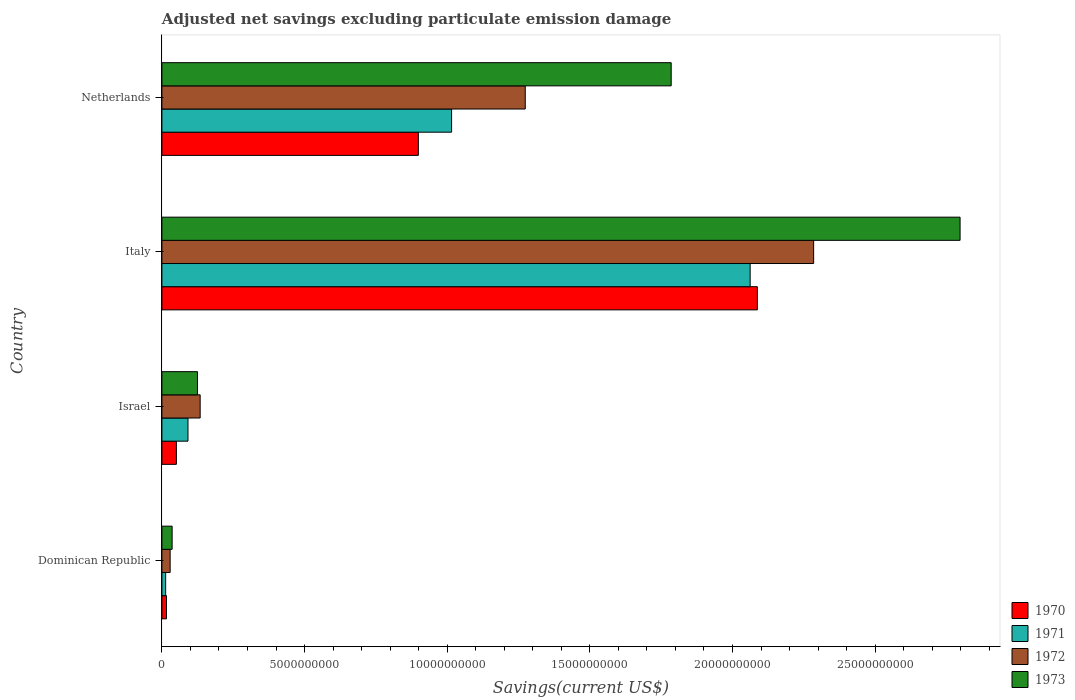How many bars are there on the 1st tick from the top?
Keep it short and to the point. 4. What is the adjusted net savings in 1971 in Israel?
Give a very brief answer. 9.14e+08. Across all countries, what is the maximum adjusted net savings in 1973?
Your response must be concise. 2.80e+1. Across all countries, what is the minimum adjusted net savings in 1971?
Provide a succinct answer. 1.32e+08. In which country was the adjusted net savings in 1973 minimum?
Make the answer very short. Dominican Republic. What is the total adjusted net savings in 1970 in the graph?
Offer a very short reply. 3.05e+1. What is the difference between the adjusted net savings in 1973 in Dominican Republic and that in Italy?
Your answer should be compact. -2.76e+1. What is the difference between the adjusted net savings in 1972 in Italy and the adjusted net savings in 1973 in Israel?
Provide a succinct answer. 2.16e+1. What is the average adjusted net savings in 1972 per country?
Your answer should be very brief. 9.30e+09. What is the difference between the adjusted net savings in 1971 and adjusted net savings in 1973 in Israel?
Make the answer very short. -3.33e+08. What is the ratio of the adjusted net savings in 1970 in Israel to that in Italy?
Provide a succinct answer. 0.02. Is the adjusted net savings in 1972 in Dominican Republic less than that in Netherlands?
Ensure brevity in your answer.  Yes. Is the difference between the adjusted net savings in 1971 in Italy and Netherlands greater than the difference between the adjusted net savings in 1973 in Italy and Netherlands?
Your response must be concise. Yes. What is the difference between the highest and the second highest adjusted net savings in 1972?
Make the answer very short. 1.01e+1. What is the difference between the highest and the lowest adjusted net savings in 1973?
Make the answer very short. 2.76e+1. Is it the case that in every country, the sum of the adjusted net savings in 1970 and adjusted net savings in 1973 is greater than the sum of adjusted net savings in 1971 and adjusted net savings in 1972?
Offer a terse response. No. What does the 2nd bar from the top in Netherlands represents?
Keep it short and to the point. 1972. How many countries are there in the graph?
Offer a terse response. 4. What is the difference between two consecutive major ticks on the X-axis?
Provide a short and direct response. 5.00e+09. Are the values on the major ticks of X-axis written in scientific E-notation?
Provide a succinct answer. No. Where does the legend appear in the graph?
Provide a succinct answer. Bottom right. How many legend labels are there?
Offer a very short reply. 4. What is the title of the graph?
Make the answer very short. Adjusted net savings excluding particulate emission damage. Does "1984" appear as one of the legend labels in the graph?
Keep it short and to the point. No. What is the label or title of the X-axis?
Provide a short and direct response. Savings(current US$). What is the Savings(current US$) in 1970 in Dominican Republic?
Your answer should be compact. 1.61e+08. What is the Savings(current US$) in 1971 in Dominican Republic?
Keep it short and to the point. 1.32e+08. What is the Savings(current US$) in 1972 in Dominican Republic?
Offer a terse response. 2.89e+08. What is the Savings(current US$) of 1973 in Dominican Republic?
Your response must be concise. 3.58e+08. What is the Savings(current US$) of 1970 in Israel?
Give a very brief answer. 5.08e+08. What is the Savings(current US$) of 1971 in Israel?
Your response must be concise. 9.14e+08. What is the Savings(current US$) in 1972 in Israel?
Make the answer very short. 1.34e+09. What is the Savings(current US$) of 1973 in Israel?
Provide a short and direct response. 1.25e+09. What is the Savings(current US$) in 1970 in Italy?
Offer a terse response. 2.09e+1. What is the Savings(current US$) in 1971 in Italy?
Your answer should be very brief. 2.06e+1. What is the Savings(current US$) of 1972 in Italy?
Ensure brevity in your answer.  2.28e+1. What is the Savings(current US$) in 1973 in Italy?
Keep it short and to the point. 2.80e+1. What is the Savings(current US$) in 1970 in Netherlands?
Provide a short and direct response. 8.99e+09. What is the Savings(current US$) of 1971 in Netherlands?
Ensure brevity in your answer.  1.02e+1. What is the Savings(current US$) in 1972 in Netherlands?
Your answer should be very brief. 1.27e+1. What is the Savings(current US$) in 1973 in Netherlands?
Your answer should be compact. 1.79e+1. Across all countries, what is the maximum Savings(current US$) of 1970?
Your answer should be very brief. 2.09e+1. Across all countries, what is the maximum Savings(current US$) of 1971?
Ensure brevity in your answer.  2.06e+1. Across all countries, what is the maximum Savings(current US$) of 1972?
Provide a succinct answer. 2.28e+1. Across all countries, what is the maximum Savings(current US$) in 1973?
Your response must be concise. 2.80e+1. Across all countries, what is the minimum Savings(current US$) in 1970?
Your answer should be compact. 1.61e+08. Across all countries, what is the minimum Savings(current US$) in 1971?
Offer a very short reply. 1.32e+08. Across all countries, what is the minimum Savings(current US$) in 1972?
Your response must be concise. 2.89e+08. Across all countries, what is the minimum Savings(current US$) in 1973?
Your answer should be compact. 3.58e+08. What is the total Savings(current US$) of 1970 in the graph?
Offer a very short reply. 3.05e+1. What is the total Savings(current US$) in 1971 in the graph?
Ensure brevity in your answer.  3.18e+1. What is the total Savings(current US$) in 1972 in the graph?
Offer a very short reply. 3.72e+1. What is the total Savings(current US$) of 1973 in the graph?
Provide a succinct answer. 4.74e+1. What is the difference between the Savings(current US$) of 1970 in Dominican Republic and that in Israel?
Make the answer very short. -3.47e+08. What is the difference between the Savings(current US$) in 1971 in Dominican Republic and that in Israel?
Your answer should be compact. -7.83e+08. What is the difference between the Savings(current US$) in 1972 in Dominican Republic and that in Israel?
Give a very brief answer. -1.05e+09. What is the difference between the Savings(current US$) of 1973 in Dominican Republic and that in Israel?
Keep it short and to the point. -8.89e+08. What is the difference between the Savings(current US$) in 1970 in Dominican Republic and that in Italy?
Ensure brevity in your answer.  -2.07e+1. What is the difference between the Savings(current US$) in 1971 in Dominican Republic and that in Italy?
Your answer should be compact. -2.05e+1. What is the difference between the Savings(current US$) of 1972 in Dominican Republic and that in Italy?
Keep it short and to the point. -2.26e+1. What is the difference between the Savings(current US$) of 1973 in Dominican Republic and that in Italy?
Make the answer very short. -2.76e+1. What is the difference between the Savings(current US$) in 1970 in Dominican Republic and that in Netherlands?
Provide a short and direct response. -8.83e+09. What is the difference between the Savings(current US$) in 1971 in Dominican Republic and that in Netherlands?
Offer a terse response. -1.00e+1. What is the difference between the Savings(current US$) in 1972 in Dominican Republic and that in Netherlands?
Provide a succinct answer. -1.24e+1. What is the difference between the Savings(current US$) in 1973 in Dominican Republic and that in Netherlands?
Keep it short and to the point. -1.75e+1. What is the difference between the Savings(current US$) of 1970 in Israel and that in Italy?
Provide a succinct answer. -2.04e+1. What is the difference between the Savings(current US$) of 1971 in Israel and that in Italy?
Keep it short and to the point. -1.97e+1. What is the difference between the Savings(current US$) in 1972 in Israel and that in Italy?
Make the answer very short. -2.15e+1. What is the difference between the Savings(current US$) in 1973 in Israel and that in Italy?
Offer a very short reply. -2.67e+1. What is the difference between the Savings(current US$) of 1970 in Israel and that in Netherlands?
Make the answer very short. -8.48e+09. What is the difference between the Savings(current US$) in 1971 in Israel and that in Netherlands?
Ensure brevity in your answer.  -9.24e+09. What is the difference between the Savings(current US$) of 1972 in Israel and that in Netherlands?
Give a very brief answer. -1.14e+1. What is the difference between the Savings(current US$) of 1973 in Israel and that in Netherlands?
Keep it short and to the point. -1.66e+1. What is the difference between the Savings(current US$) in 1970 in Italy and that in Netherlands?
Your answer should be compact. 1.19e+1. What is the difference between the Savings(current US$) of 1971 in Italy and that in Netherlands?
Offer a very short reply. 1.05e+1. What is the difference between the Savings(current US$) in 1972 in Italy and that in Netherlands?
Provide a succinct answer. 1.01e+1. What is the difference between the Savings(current US$) of 1973 in Italy and that in Netherlands?
Your answer should be very brief. 1.01e+1. What is the difference between the Savings(current US$) in 1970 in Dominican Republic and the Savings(current US$) in 1971 in Israel?
Give a very brief answer. -7.53e+08. What is the difference between the Savings(current US$) of 1970 in Dominican Republic and the Savings(current US$) of 1972 in Israel?
Give a very brief answer. -1.18e+09. What is the difference between the Savings(current US$) in 1970 in Dominican Republic and the Savings(current US$) in 1973 in Israel?
Make the answer very short. -1.09e+09. What is the difference between the Savings(current US$) of 1971 in Dominican Republic and the Savings(current US$) of 1972 in Israel?
Give a very brief answer. -1.21e+09. What is the difference between the Savings(current US$) of 1971 in Dominican Republic and the Savings(current US$) of 1973 in Israel?
Offer a very short reply. -1.12e+09. What is the difference between the Savings(current US$) of 1972 in Dominican Republic and the Savings(current US$) of 1973 in Israel?
Make the answer very short. -9.58e+08. What is the difference between the Savings(current US$) in 1970 in Dominican Republic and the Savings(current US$) in 1971 in Italy?
Your response must be concise. -2.05e+1. What is the difference between the Savings(current US$) in 1970 in Dominican Republic and the Savings(current US$) in 1972 in Italy?
Your answer should be compact. -2.27e+1. What is the difference between the Savings(current US$) of 1970 in Dominican Republic and the Savings(current US$) of 1973 in Italy?
Ensure brevity in your answer.  -2.78e+1. What is the difference between the Savings(current US$) in 1971 in Dominican Republic and the Savings(current US$) in 1972 in Italy?
Provide a short and direct response. -2.27e+1. What is the difference between the Savings(current US$) in 1971 in Dominican Republic and the Savings(current US$) in 1973 in Italy?
Your answer should be very brief. -2.78e+1. What is the difference between the Savings(current US$) of 1972 in Dominican Republic and the Savings(current US$) of 1973 in Italy?
Offer a terse response. -2.77e+1. What is the difference between the Savings(current US$) of 1970 in Dominican Republic and the Savings(current US$) of 1971 in Netherlands?
Provide a short and direct response. -9.99e+09. What is the difference between the Savings(current US$) of 1970 in Dominican Republic and the Savings(current US$) of 1972 in Netherlands?
Keep it short and to the point. -1.26e+1. What is the difference between the Savings(current US$) of 1970 in Dominican Republic and the Savings(current US$) of 1973 in Netherlands?
Provide a succinct answer. -1.77e+1. What is the difference between the Savings(current US$) in 1971 in Dominican Republic and the Savings(current US$) in 1972 in Netherlands?
Make the answer very short. -1.26e+1. What is the difference between the Savings(current US$) in 1971 in Dominican Republic and the Savings(current US$) in 1973 in Netherlands?
Your answer should be compact. -1.77e+1. What is the difference between the Savings(current US$) of 1972 in Dominican Republic and the Savings(current US$) of 1973 in Netherlands?
Offer a very short reply. -1.76e+1. What is the difference between the Savings(current US$) in 1970 in Israel and the Savings(current US$) in 1971 in Italy?
Give a very brief answer. -2.01e+1. What is the difference between the Savings(current US$) in 1970 in Israel and the Savings(current US$) in 1972 in Italy?
Ensure brevity in your answer.  -2.23e+1. What is the difference between the Savings(current US$) in 1970 in Israel and the Savings(current US$) in 1973 in Italy?
Your answer should be compact. -2.75e+1. What is the difference between the Savings(current US$) in 1971 in Israel and the Savings(current US$) in 1972 in Italy?
Offer a very short reply. -2.19e+1. What is the difference between the Savings(current US$) of 1971 in Israel and the Savings(current US$) of 1973 in Italy?
Give a very brief answer. -2.71e+1. What is the difference between the Savings(current US$) of 1972 in Israel and the Savings(current US$) of 1973 in Italy?
Make the answer very short. -2.66e+1. What is the difference between the Savings(current US$) of 1970 in Israel and the Savings(current US$) of 1971 in Netherlands?
Your response must be concise. -9.65e+09. What is the difference between the Savings(current US$) of 1970 in Israel and the Savings(current US$) of 1972 in Netherlands?
Give a very brief answer. -1.22e+1. What is the difference between the Savings(current US$) of 1970 in Israel and the Savings(current US$) of 1973 in Netherlands?
Give a very brief answer. -1.73e+1. What is the difference between the Savings(current US$) in 1971 in Israel and the Savings(current US$) in 1972 in Netherlands?
Make the answer very short. -1.18e+1. What is the difference between the Savings(current US$) of 1971 in Israel and the Savings(current US$) of 1973 in Netherlands?
Your answer should be compact. -1.69e+1. What is the difference between the Savings(current US$) in 1972 in Israel and the Savings(current US$) in 1973 in Netherlands?
Your response must be concise. -1.65e+1. What is the difference between the Savings(current US$) of 1970 in Italy and the Savings(current US$) of 1971 in Netherlands?
Give a very brief answer. 1.07e+1. What is the difference between the Savings(current US$) of 1970 in Italy and the Savings(current US$) of 1972 in Netherlands?
Provide a succinct answer. 8.14e+09. What is the difference between the Savings(current US$) of 1970 in Italy and the Savings(current US$) of 1973 in Netherlands?
Make the answer very short. 3.02e+09. What is the difference between the Savings(current US$) of 1971 in Italy and the Savings(current US$) of 1972 in Netherlands?
Provide a succinct answer. 7.88e+09. What is the difference between the Savings(current US$) of 1971 in Italy and the Savings(current US$) of 1973 in Netherlands?
Offer a very short reply. 2.77e+09. What is the difference between the Savings(current US$) in 1972 in Italy and the Savings(current US$) in 1973 in Netherlands?
Offer a terse response. 4.99e+09. What is the average Savings(current US$) in 1970 per country?
Provide a succinct answer. 7.63e+09. What is the average Savings(current US$) in 1971 per country?
Ensure brevity in your answer.  7.95e+09. What is the average Savings(current US$) of 1972 per country?
Offer a very short reply. 9.30e+09. What is the average Savings(current US$) in 1973 per country?
Keep it short and to the point. 1.19e+1. What is the difference between the Savings(current US$) in 1970 and Savings(current US$) in 1971 in Dominican Republic?
Provide a succinct answer. 2.96e+07. What is the difference between the Savings(current US$) of 1970 and Savings(current US$) of 1972 in Dominican Republic?
Offer a terse response. -1.28e+08. What is the difference between the Savings(current US$) in 1970 and Savings(current US$) in 1973 in Dominican Republic?
Offer a very short reply. -1.97e+08. What is the difference between the Savings(current US$) in 1971 and Savings(current US$) in 1972 in Dominican Republic?
Offer a very short reply. -1.57e+08. What is the difference between the Savings(current US$) of 1971 and Savings(current US$) of 1973 in Dominican Republic?
Offer a very short reply. -2.27e+08. What is the difference between the Savings(current US$) of 1972 and Savings(current US$) of 1973 in Dominican Republic?
Your answer should be compact. -6.95e+07. What is the difference between the Savings(current US$) of 1970 and Savings(current US$) of 1971 in Israel?
Provide a short and direct response. -4.06e+08. What is the difference between the Savings(current US$) of 1970 and Savings(current US$) of 1972 in Israel?
Provide a short and direct response. -8.33e+08. What is the difference between the Savings(current US$) of 1970 and Savings(current US$) of 1973 in Israel?
Ensure brevity in your answer.  -7.39e+08. What is the difference between the Savings(current US$) of 1971 and Savings(current US$) of 1972 in Israel?
Provide a short and direct response. -4.27e+08. What is the difference between the Savings(current US$) in 1971 and Savings(current US$) in 1973 in Israel?
Give a very brief answer. -3.33e+08. What is the difference between the Savings(current US$) of 1972 and Savings(current US$) of 1973 in Israel?
Make the answer very short. 9.40e+07. What is the difference between the Savings(current US$) in 1970 and Savings(current US$) in 1971 in Italy?
Provide a short and direct response. 2.53e+08. What is the difference between the Savings(current US$) of 1970 and Savings(current US$) of 1972 in Italy?
Provide a short and direct response. -1.97e+09. What is the difference between the Savings(current US$) in 1970 and Savings(current US$) in 1973 in Italy?
Your response must be concise. -7.11e+09. What is the difference between the Savings(current US$) in 1971 and Savings(current US$) in 1972 in Italy?
Offer a very short reply. -2.23e+09. What is the difference between the Savings(current US$) of 1971 and Savings(current US$) of 1973 in Italy?
Your answer should be compact. -7.36e+09. What is the difference between the Savings(current US$) of 1972 and Savings(current US$) of 1973 in Italy?
Provide a short and direct response. -5.13e+09. What is the difference between the Savings(current US$) in 1970 and Savings(current US$) in 1971 in Netherlands?
Make the answer very short. -1.17e+09. What is the difference between the Savings(current US$) of 1970 and Savings(current US$) of 1972 in Netherlands?
Ensure brevity in your answer.  -3.75e+09. What is the difference between the Savings(current US$) in 1970 and Savings(current US$) in 1973 in Netherlands?
Your answer should be very brief. -8.86e+09. What is the difference between the Savings(current US$) in 1971 and Savings(current US$) in 1972 in Netherlands?
Offer a very short reply. -2.58e+09. What is the difference between the Savings(current US$) in 1971 and Savings(current US$) in 1973 in Netherlands?
Provide a succinct answer. -7.70e+09. What is the difference between the Savings(current US$) in 1972 and Savings(current US$) in 1973 in Netherlands?
Your answer should be very brief. -5.11e+09. What is the ratio of the Savings(current US$) of 1970 in Dominican Republic to that in Israel?
Provide a succinct answer. 0.32. What is the ratio of the Savings(current US$) of 1971 in Dominican Republic to that in Israel?
Give a very brief answer. 0.14. What is the ratio of the Savings(current US$) in 1972 in Dominican Republic to that in Israel?
Offer a terse response. 0.22. What is the ratio of the Savings(current US$) of 1973 in Dominican Republic to that in Israel?
Give a very brief answer. 0.29. What is the ratio of the Savings(current US$) in 1970 in Dominican Republic to that in Italy?
Keep it short and to the point. 0.01. What is the ratio of the Savings(current US$) of 1971 in Dominican Republic to that in Italy?
Make the answer very short. 0.01. What is the ratio of the Savings(current US$) in 1972 in Dominican Republic to that in Italy?
Ensure brevity in your answer.  0.01. What is the ratio of the Savings(current US$) in 1973 in Dominican Republic to that in Italy?
Make the answer very short. 0.01. What is the ratio of the Savings(current US$) in 1970 in Dominican Republic to that in Netherlands?
Provide a short and direct response. 0.02. What is the ratio of the Savings(current US$) in 1971 in Dominican Republic to that in Netherlands?
Provide a short and direct response. 0.01. What is the ratio of the Savings(current US$) of 1972 in Dominican Republic to that in Netherlands?
Your answer should be very brief. 0.02. What is the ratio of the Savings(current US$) in 1973 in Dominican Republic to that in Netherlands?
Ensure brevity in your answer.  0.02. What is the ratio of the Savings(current US$) in 1970 in Israel to that in Italy?
Make the answer very short. 0.02. What is the ratio of the Savings(current US$) in 1971 in Israel to that in Italy?
Give a very brief answer. 0.04. What is the ratio of the Savings(current US$) in 1972 in Israel to that in Italy?
Provide a short and direct response. 0.06. What is the ratio of the Savings(current US$) of 1973 in Israel to that in Italy?
Offer a very short reply. 0.04. What is the ratio of the Savings(current US$) in 1970 in Israel to that in Netherlands?
Give a very brief answer. 0.06. What is the ratio of the Savings(current US$) in 1971 in Israel to that in Netherlands?
Your answer should be very brief. 0.09. What is the ratio of the Savings(current US$) in 1972 in Israel to that in Netherlands?
Your response must be concise. 0.11. What is the ratio of the Savings(current US$) of 1973 in Israel to that in Netherlands?
Your answer should be very brief. 0.07. What is the ratio of the Savings(current US$) in 1970 in Italy to that in Netherlands?
Your answer should be compact. 2.32. What is the ratio of the Savings(current US$) of 1971 in Italy to that in Netherlands?
Make the answer very short. 2.03. What is the ratio of the Savings(current US$) in 1972 in Italy to that in Netherlands?
Keep it short and to the point. 1.79. What is the ratio of the Savings(current US$) in 1973 in Italy to that in Netherlands?
Offer a terse response. 1.57. What is the difference between the highest and the second highest Savings(current US$) of 1970?
Offer a terse response. 1.19e+1. What is the difference between the highest and the second highest Savings(current US$) in 1971?
Make the answer very short. 1.05e+1. What is the difference between the highest and the second highest Savings(current US$) in 1972?
Make the answer very short. 1.01e+1. What is the difference between the highest and the second highest Savings(current US$) in 1973?
Ensure brevity in your answer.  1.01e+1. What is the difference between the highest and the lowest Savings(current US$) in 1970?
Make the answer very short. 2.07e+1. What is the difference between the highest and the lowest Savings(current US$) in 1971?
Ensure brevity in your answer.  2.05e+1. What is the difference between the highest and the lowest Savings(current US$) in 1972?
Your answer should be very brief. 2.26e+1. What is the difference between the highest and the lowest Savings(current US$) of 1973?
Make the answer very short. 2.76e+1. 